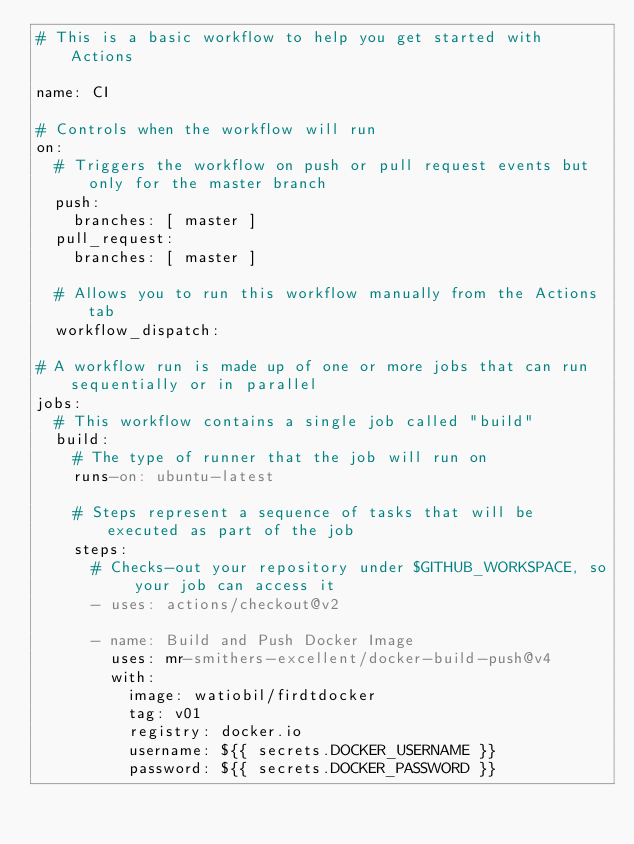Convert code to text. <code><loc_0><loc_0><loc_500><loc_500><_YAML_># This is a basic workflow to help you get started with Actions 

name: CI

# Controls when the workflow will run
on:
  # Triggers the workflow on push or pull request events but only for the master branch
  push:
    branches: [ master ]
  pull_request:
    branches: [ master ]

  # Allows you to run this workflow manually from the Actions tab
  workflow_dispatch:

# A workflow run is made up of one or more jobs that can run sequentially or in parallel
jobs:
  # This workflow contains a single job called "build"
  build:
    # The type of runner that the job will run on
    runs-on: ubuntu-latest

    # Steps represent a sequence of tasks that will be executed as part of the job
    steps:
      # Checks-out your repository under $GITHUB_WORKSPACE, so your job can access it
      - uses: actions/checkout@v2

      - name: Build and Push Docker Image
        uses: mr-smithers-excellent/docker-build-push@v4
        with:
          image: watiobil/firdtdocker 
          tag: v01
          registry: docker.io
          username: ${{ secrets.DOCKER_USERNAME }}
          password: ${{ secrets.DOCKER_PASSWORD }}
</code> 